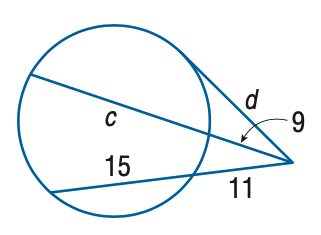Answer the mathemtical geometry problem and directly provide the correct option letter.
Question: Find the variable of d to the nearest tenth. Assume that segments that appear to be tangent are tangent.
Choices: A: 12.8 B: 14.7 C: 16.9 D: 18.2 C 